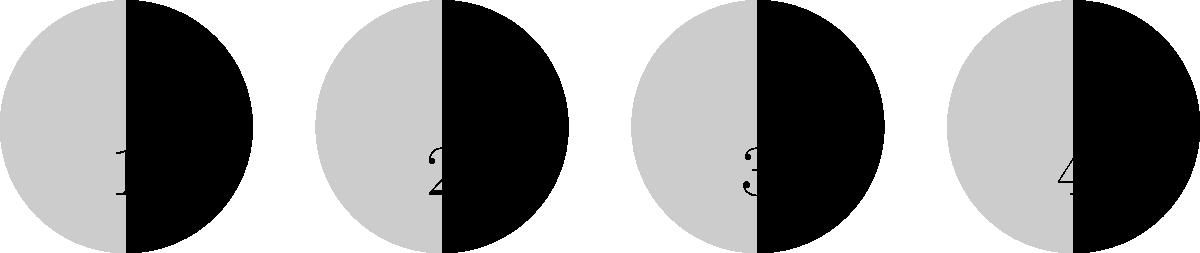As a local government representative, you're tasked with organizing a public astronomy event. To ensure accurate information is presented, you need to verify the correct sequence of moon phases. In the diagram above, which number represents the waxing gibbous phase of the moon? To answer this question, let's break down the moon phases and their characteristics:

1. New Moon: The moon is not visible from Earth (0% illumination).
2. Waxing Crescent: Less than half of the moon's visible surface is illuminated, increasing (right side visible).
3. First Quarter: Half of the moon's visible surface is illuminated (right half visible).
4. Waxing Gibbous: More than half, but not all, of the moon's visible surface is illuminated, increasing (right side fuller).
5. Full Moon: The entire visible surface of the moon is illuminated (100% visible).
6. Waning Gibbous: More than half, but not all, of the moon's visible surface is illuminated, decreasing (left side fuller).
7. Last Quarter: Half of the moon's visible surface is illuminated (left half visible).
8. Waning Crescent: Less than half of the moon's visible surface is illuminated, decreasing (left side visible).

Looking at the diagram:
1. Image 1 shows a waxing crescent (small right portion illuminated).
2. Image 2 shows a waxing gibbous (more than half, right side illuminated).
3. Image 3 shows a waning gibbous (more than half, left side illuminated).
4. Image 4 shows a waning crescent (small left portion illuminated).

The waxing gibbous phase is represented by image 2 in the diagram.
Answer: 2 